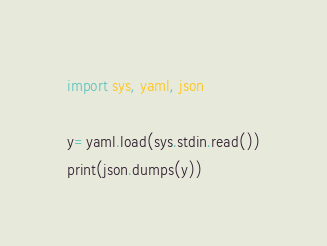<code> <loc_0><loc_0><loc_500><loc_500><_Python_>import sys, yaml, json

y=yaml.load(sys.stdin.read())
print(json.dumps(y))</code> 